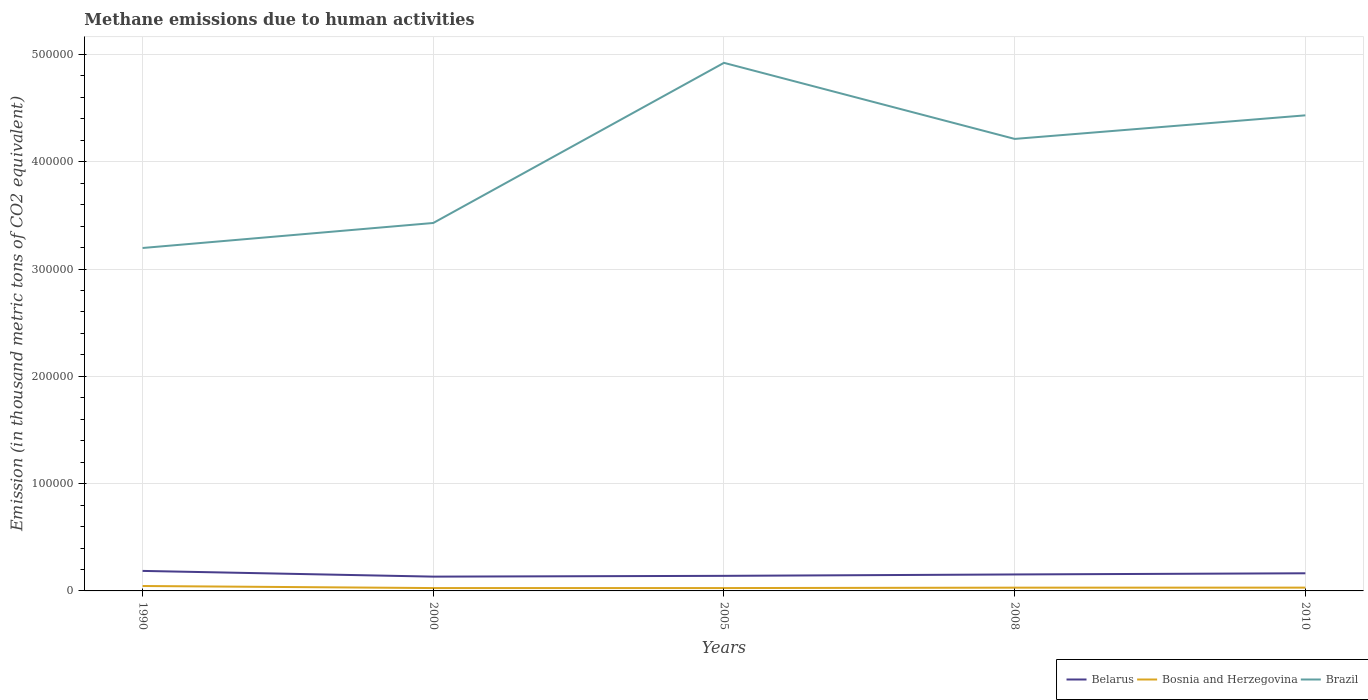Does the line corresponding to Bosnia and Herzegovina intersect with the line corresponding to Belarus?
Your answer should be very brief. No. Across all years, what is the maximum amount of methane emitted in Belarus?
Offer a terse response. 1.33e+04. What is the total amount of methane emitted in Bosnia and Herzegovina in the graph?
Make the answer very short. -399.7. What is the difference between the highest and the second highest amount of methane emitted in Belarus?
Your answer should be compact. 5333.7. Is the amount of methane emitted in Bosnia and Herzegovina strictly greater than the amount of methane emitted in Brazil over the years?
Ensure brevity in your answer.  Yes. How many lines are there?
Offer a very short reply. 3. Are the values on the major ticks of Y-axis written in scientific E-notation?
Your answer should be very brief. No. Does the graph contain any zero values?
Ensure brevity in your answer.  No. How many legend labels are there?
Ensure brevity in your answer.  3. How are the legend labels stacked?
Provide a short and direct response. Horizontal. What is the title of the graph?
Provide a short and direct response. Methane emissions due to human activities. What is the label or title of the X-axis?
Make the answer very short. Years. What is the label or title of the Y-axis?
Your response must be concise. Emission (in thousand metric tons of CO2 equivalent). What is the Emission (in thousand metric tons of CO2 equivalent) in Belarus in 1990?
Keep it short and to the point. 1.87e+04. What is the Emission (in thousand metric tons of CO2 equivalent) in Bosnia and Herzegovina in 1990?
Offer a terse response. 4589.8. What is the Emission (in thousand metric tons of CO2 equivalent) of Brazil in 1990?
Keep it short and to the point. 3.20e+05. What is the Emission (in thousand metric tons of CO2 equivalent) in Belarus in 2000?
Ensure brevity in your answer.  1.33e+04. What is the Emission (in thousand metric tons of CO2 equivalent) in Bosnia and Herzegovina in 2000?
Provide a short and direct response. 2671.7. What is the Emission (in thousand metric tons of CO2 equivalent) in Brazil in 2000?
Ensure brevity in your answer.  3.43e+05. What is the Emission (in thousand metric tons of CO2 equivalent) in Belarus in 2005?
Provide a succinct answer. 1.40e+04. What is the Emission (in thousand metric tons of CO2 equivalent) in Bosnia and Herzegovina in 2005?
Provide a succinct answer. 2665.7. What is the Emission (in thousand metric tons of CO2 equivalent) of Brazil in 2005?
Offer a terse response. 4.92e+05. What is the Emission (in thousand metric tons of CO2 equivalent) of Belarus in 2008?
Provide a short and direct response. 1.53e+04. What is the Emission (in thousand metric tons of CO2 equivalent) in Bosnia and Herzegovina in 2008?
Offer a very short reply. 3037.4. What is the Emission (in thousand metric tons of CO2 equivalent) of Brazil in 2008?
Keep it short and to the point. 4.21e+05. What is the Emission (in thousand metric tons of CO2 equivalent) in Belarus in 2010?
Offer a very short reply. 1.64e+04. What is the Emission (in thousand metric tons of CO2 equivalent) of Bosnia and Herzegovina in 2010?
Keep it short and to the point. 3071.4. What is the Emission (in thousand metric tons of CO2 equivalent) in Brazil in 2010?
Ensure brevity in your answer.  4.43e+05. Across all years, what is the maximum Emission (in thousand metric tons of CO2 equivalent) in Belarus?
Ensure brevity in your answer.  1.87e+04. Across all years, what is the maximum Emission (in thousand metric tons of CO2 equivalent) in Bosnia and Herzegovina?
Keep it short and to the point. 4589.8. Across all years, what is the maximum Emission (in thousand metric tons of CO2 equivalent) of Brazil?
Provide a succinct answer. 4.92e+05. Across all years, what is the minimum Emission (in thousand metric tons of CO2 equivalent) of Belarus?
Your response must be concise. 1.33e+04. Across all years, what is the minimum Emission (in thousand metric tons of CO2 equivalent) of Bosnia and Herzegovina?
Offer a terse response. 2665.7. Across all years, what is the minimum Emission (in thousand metric tons of CO2 equivalent) of Brazil?
Your answer should be very brief. 3.20e+05. What is the total Emission (in thousand metric tons of CO2 equivalent) in Belarus in the graph?
Keep it short and to the point. 7.78e+04. What is the total Emission (in thousand metric tons of CO2 equivalent) in Bosnia and Herzegovina in the graph?
Offer a very short reply. 1.60e+04. What is the total Emission (in thousand metric tons of CO2 equivalent) of Brazil in the graph?
Make the answer very short. 2.02e+06. What is the difference between the Emission (in thousand metric tons of CO2 equivalent) in Belarus in 1990 and that in 2000?
Make the answer very short. 5333.7. What is the difference between the Emission (in thousand metric tons of CO2 equivalent) in Bosnia and Herzegovina in 1990 and that in 2000?
Provide a short and direct response. 1918.1. What is the difference between the Emission (in thousand metric tons of CO2 equivalent) of Brazil in 1990 and that in 2000?
Provide a short and direct response. -2.33e+04. What is the difference between the Emission (in thousand metric tons of CO2 equivalent) of Belarus in 1990 and that in 2005?
Provide a succinct answer. 4610.7. What is the difference between the Emission (in thousand metric tons of CO2 equivalent) in Bosnia and Herzegovina in 1990 and that in 2005?
Give a very brief answer. 1924.1. What is the difference between the Emission (in thousand metric tons of CO2 equivalent) in Brazil in 1990 and that in 2005?
Your answer should be compact. -1.73e+05. What is the difference between the Emission (in thousand metric tons of CO2 equivalent) of Belarus in 1990 and that in 2008?
Your response must be concise. 3312.9. What is the difference between the Emission (in thousand metric tons of CO2 equivalent) in Bosnia and Herzegovina in 1990 and that in 2008?
Keep it short and to the point. 1552.4. What is the difference between the Emission (in thousand metric tons of CO2 equivalent) of Brazil in 1990 and that in 2008?
Provide a succinct answer. -1.02e+05. What is the difference between the Emission (in thousand metric tons of CO2 equivalent) in Belarus in 1990 and that in 2010?
Make the answer very short. 2221. What is the difference between the Emission (in thousand metric tons of CO2 equivalent) in Bosnia and Herzegovina in 1990 and that in 2010?
Make the answer very short. 1518.4. What is the difference between the Emission (in thousand metric tons of CO2 equivalent) of Brazil in 1990 and that in 2010?
Your answer should be compact. -1.24e+05. What is the difference between the Emission (in thousand metric tons of CO2 equivalent) of Belarus in 2000 and that in 2005?
Provide a succinct answer. -723. What is the difference between the Emission (in thousand metric tons of CO2 equivalent) of Bosnia and Herzegovina in 2000 and that in 2005?
Your answer should be very brief. 6. What is the difference between the Emission (in thousand metric tons of CO2 equivalent) in Brazil in 2000 and that in 2005?
Offer a terse response. -1.49e+05. What is the difference between the Emission (in thousand metric tons of CO2 equivalent) of Belarus in 2000 and that in 2008?
Your answer should be compact. -2020.8. What is the difference between the Emission (in thousand metric tons of CO2 equivalent) in Bosnia and Herzegovina in 2000 and that in 2008?
Make the answer very short. -365.7. What is the difference between the Emission (in thousand metric tons of CO2 equivalent) of Brazil in 2000 and that in 2008?
Ensure brevity in your answer.  -7.84e+04. What is the difference between the Emission (in thousand metric tons of CO2 equivalent) in Belarus in 2000 and that in 2010?
Provide a succinct answer. -3112.7. What is the difference between the Emission (in thousand metric tons of CO2 equivalent) in Bosnia and Herzegovina in 2000 and that in 2010?
Offer a very short reply. -399.7. What is the difference between the Emission (in thousand metric tons of CO2 equivalent) of Brazil in 2000 and that in 2010?
Your answer should be compact. -1.00e+05. What is the difference between the Emission (in thousand metric tons of CO2 equivalent) of Belarus in 2005 and that in 2008?
Keep it short and to the point. -1297.8. What is the difference between the Emission (in thousand metric tons of CO2 equivalent) of Bosnia and Herzegovina in 2005 and that in 2008?
Your answer should be very brief. -371.7. What is the difference between the Emission (in thousand metric tons of CO2 equivalent) in Brazil in 2005 and that in 2008?
Keep it short and to the point. 7.09e+04. What is the difference between the Emission (in thousand metric tons of CO2 equivalent) in Belarus in 2005 and that in 2010?
Keep it short and to the point. -2389.7. What is the difference between the Emission (in thousand metric tons of CO2 equivalent) of Bosnia and Herzegovina in 2005 and that in 2010?
Keep it short and to the point. -405.7. What is the difference between the Emission (in thousand metric tons of CO2 equivalent) in Brazil in 2005 and that in 2010?
Your answer should be very brief. 4.89e+04. What is the difference between the Emission (in thousand metric tons of CO2 equivalent) in Belarus in 2008 and that in 2010?
Offer a very short reply. -1091.9. What is the difference between the Emission (in thousand metric tons of CO2 equivalent) in Bosnia and Herzegovina in 2008 and that in 2010?
Provide a short and direct response. -34. What is the difference between the Emission (in thousand metric tons of CO2 equivalent) of Brazil in 2008 and that in 2010?
Offer a terse response. -2.20e+04. What is the difference between the Emission (in thousand metric tons of CO2 equivalent) in Belarus in 1990 and the Emission (in thousand metric tons of CO2 equivalent) in Bosnia and Herzegovina in 2000?
Your answer should be very brief. 1.60e+04. What is the difference between the Emission (in thousand metric tons of CO2 equivalent) in Belarus in 1990 and the Emission (in thousand metric tons of CO2 equivalent) in Brazil in 2000?
Make the answer very short. -3.24e+05. What is the difference between the Emission (in thousand metric tons of CO2 equivalent) in Bosnia and Herzegovina in 1990 and the Emission (in thousand metric tons of CO2 equivalent) in Brazil in 2000?
Your answer should be compact. -3.38e+05. What is the difference between the Emission (in thousand metric tons of CO2 equivalent) in Belarus in 1990 and the Emission (in thousand metric tons of CO2 equivalent) in Bosnia and Herzegovina in 2005?
Your answer should be compact. 1.60e+04. What is the difference between the Emission (in thousand metric tons of CO2 equivalent) in Belarus in 1990 and the Emission (in thousand metric tons of CO2 equivalent) in Brazil in 2005?
Offer a very short reply. -4.74e+05. What is the difference between the Emission (in thousand metric tons of CO2 equivalent) in Bosnia and Herzegovina in 1990 and the Emission (in thousand metric tons of CO2 equivalent) in Brazil in 2005?
Your answer should be compact. -4.88e+05. What is the difference between the Emission (in thousand metric tons of CO2 equivalent) of Belarus in 1990 and the Emission (in thousand metric tons of CO2 equivalent) of Bosnia and Herzegovina in 2008?
Offer a very short reply. 1.56e+04. What is the difference between the Emission (in thousand metric tons of CO2 equivalent) in Belarus in 1990 and the Emission (in thousand metric tons of CO2 equivalent) in Brazil in 2008?
Your answer should be compact. -4.03e+05. What is the difference between the Emission (in thousand metric tons of CO2 equivalent) in Bosnia and Herzegovina in 1990 and the Emission (in thousand metric tons of CO2 equivalent) in Brazil in 2008?
Keep it short and to the point. -4.17e+05. What is the difference between the Emission (in thousand metric tons of CO2 equivalent) of Belarus in 1990 and the Emission (in thousand metric tons of CO2 equivalent) of Bosnia and Herzegovina in 2010?
Keep it short and to the point. 1.56e+04. What is the difference between the Emission (in thousand metric tons of CO2 equivalent) in Belarus in 1990 and the Emission (in thousand metric tons of CO2 equivalent) in Brazil in 2010?
Your answer should be very brief. -4.25e+05. What is the difference between the Emission (in thousand metric tons of CO2 equivalent) of Bosnia and Herzegovina in 1990 and the Emission (in thousand metric tons of CO2 equivalent) of Brazil in 2010?
Give a very brief answer. -4.39e+05. What is the difference between the Emission (in thousand metric tons of CO2 equivalent) of Belarus in 2000 and the Emission (in thousand metric tons of CO2 equivalent) of Bosnia and Herzegovina in 2005?
Offer a very short reply. 1.07e+04. What is the difference between the Emission (in thousand metric tons of CO2 equivalent) of Belarus in 2000 and the Emission (in thousand metric tons of CO2 equivalent) of Brazil in 2005?
Offer a terse response. -4.79e+05. What is the difference between the Emission (in thousand metric tons of CO2 equivalent) of Bosnia and Herzegovina in 2000 and the Emission (in thousand metric tons of CO2 equivalent) of Brazil in 2005?
Ensure brevity in your answer.  -4.90e+05. What is the difference between the Emission (in thousand metric tons of CO2 equivalent) in Belarus in 2000 and the Emission (in thousand metric tons of CO2 equivalent) in Bosnia and Herzegovina in 2008?
Your answer should be very brief. 1.03e+04. What is the difference between the Emission (in thousand metric tons of CO2 equivalent) in Belarus in 2000 and the Emission (in thousand metric tons of CO2 equivalent) in Brazil in 2008?
Provide a short and direct response. -4.08e+05. What is the difference between the Emission (in thousand metric tons of CO2 equivalent) in Bosnia and Herzegovina in 2000 and the Emission (in thousand metric tons of CO2 equivalent) in Brazil in 2008?
Offer a terse response. -4.19e+05. What is the difference between the Emission (in thousand metric tons of CO2 equivalent) of Belarus in 2000 and the Emission (in thousand metric tons of CO2 equivalent) of Bosnia and Herzegovina in 2010?
Offer a terse response. 1.03e+04. What is the difference between the Emission (in thousand metric tons of CO2 equivalent) of Belarus in 2000 and the Emission (in thousand metric tons of CO2 equivalent) of Brazil in 2010?
Your response must be concise. -4.30e+05. What is the difference between the Emission (in thousand metric tons of CO2 equivalent) of Bosnia and Herzegovina in 2000 and the Emission (in thousand metric tons of CO2 equivalent) of Brazil in 2010?
Keep it short and to the point. -4.41e+05. What is the difference between the Emission (in thousand metric tons of CO2 equivalent) in Belarus in 2005 and the Emission (in thousand metric tons of CO2 equivalent) in Bosnia and Herzegovina in 2008?
Ensure brevity in your answer.  1.10e+04. What is the difference between the Emission (in thousand metric tons of CO2 equivalent) in Belarus in 2005 and the Emission (in thousand metric tons of CO2 equivalent) in Brazil in 2008?
Give a very brief answer. -4.07e+05. What is the difference between the Emission (in thousand metric tons of CO2 equivalent) in Bosnia and Herzegovina in 2005 and the Emission (in thousand metric tons of CO2 equivalent) in Brazil in 2008?
Provide a short and direct response. -4.19e+05. What is the difference between the Emission (in thousand metric tons of CO2 equivalent) of Belarus in 2005 and the Emission (in thousand metric tons of CO2 equivalent) of Bosnia and Herzegovina in 2010?
Keep it short and to the point. 1.10e+04. What is the difference between the Emission (in thousand metric tons of CO2 equivalent) of Belarus in 2005 and the Emission (in thousand metric tons of CO2 equivalent) of Brazil in 2010?
Your answer should be very brief. -4.29e+05. What is the difference between the Emission (in thousand metric tons of CO2 equivalent) in Bosnia and Herzegovina in 2005 and the Emission (in thousand metric tons of CO2 equivalent) in Brazil in 2010?
Give a very brief answer. -4.41e+05. What is the difference between the Emission (in thousand metric tons of CO2 equivalent) of Belarus in 2008 and the Emission (in thousand metric tons of CO2 equivalent) of Bosnia and Herzegovina in 2010?
Make the answer very short. 1.23e+04. What is the difference between the Emission (in thousand metric tons of CO2 equivalent) of Belarus in 2008 and the Emission (in thousand metric tons of CO2 equivalent) of Brazil in 2010?
Offer a very short reply. -4.28e+05. What is the difference between the Emission (in thousand metric tons of CO2 equivalent) in Bosnia and Herzegovina in 2008 and the Emission (in thousand metric tons of CO2 equivalent) in Brazil in 2010?
Offer a terse response. -4.40e+05. What is the average Emission (in thousand metric tons of CO2 equivalent) in Belarus per year?
Ensure brevity in your answer.  1.56e+04. What is the average Emission (in thousand metric tons of CO2 equivalent) in Bosnia and Herzegovina per year?
Give a very brief answer. 3207.2. What is the average Emission (in thousand metric tons of CO2 equivalent) of Brazil per year?
Your answer should be compact. 4.04e+05. In the year 1990, what is the difference between the Emission (in thousand metric tons of CO2 equivalent) of Belarus and Emission (in thousand metric tons of CO2 equivalent) of Bosnia and Herzegovina?
Your response must be concise. 1.41e+04. In the year 1990, what is the difference between the Emission (in thousand metric tons of CO2 equivalent) of Belarus and Emission (in thousand metric tons of CO2 equivalent) of Brazil?
Keep it short and to the point. -3.01e+05. In the year 1990, what is the difference between the Emission (in thousand metric tons of CO2 equivalent) in Bosnia and Herzegovina and Emission (in thousand metric tons of CO2 equivalent) in Brazil?
Your answer should be very brief. -3.15e+05. In the year 2000, what is the difference between the Emission (in thousand metric tons of CO2 equivalent) in Belarus and Emission (in thousand metric tons of CO2 equivalent) in Bosnia and Herzegovina?
Your answer should be compact. 1.07e+04. In the year 2000, what is the difference between the Emission (in thousand metric tons of CO2 equivalent) of Belarus and Emission (in thousand metric tons of CO2 equivalent) of Brazil?
Offer a very short reply. -3.30e+05. In the year 2000, what is the difference between the Emission (in thousand metric tons of CO2 equivalent) of Bosnia and Herzegovina and Emission (in thousand metric tons of CO2 equivalent) of Brazil?
Give a very brief answer. -3.40e+05. In the year 2005, what is the difference between the Emission (in thousand metric tons of CO2 equivalent) in Belarus and Emission (in thousand metric tons of CO2 equivalent) in Bosnia and Herzegovina?
Provide a succinct answer. 1.14e+04. In the year 2005, what is the difference between the Emission (in thousand metric tons of CO2 equivalent) of Belarus and Emission (in thousand metric tons of CO2 equivalent) of Brazil?
Offer a very short reply. -4.78e+05. In the year 2005, what is the difference between the Emission (in thousand metric tons of CO2 equivalent) in Bosnia and Herzegovina and Emission (in thousand metric tons of CO2 equivalent) in Brazil?
Ensure brevity in your answer.  -4.90e+05. In the year 2008, what is the difference between the Emission (in thousand metric tons of CO2 equivalent) of Belarus and Emission (in thousand metric tons of CO2 equivalent) of Bosnia and Herzegovina?
Your answer should be very brief. 1.23e+04. In the year 2008, what is the difference between the Emission (in thousand metric tons of CO2 equivalent) of Belarus and Emission (in thousand metric tons of CO2 equivalent) of Brazil?
Keep it short and to the point. -4.06e+05. In the year 2008, what is the difference between the Emission (in thousand metric tons of CO2 equivalent) of Bosnia and Herzegovina and Emission (in thousand metric tons of CO2 equivalent) of Brazil?
Offer a very short reply. -4.18e+05. In the year 2010, what is the difference between the Emission (in thousand metric tons of CO2 equivalent) in Belarus and Emission (in thousand metric tons of CO2 equivalent) in Bosnia and Herzegovina?
Offer a very short reply. 1.34e+04. In the year 2010, what is the difference between the Emission (in thousand metric tons of CO2 equivalent) in Belarus and Emission (in thousand metric tons of CO2 equivalent) in Brazil?
Offer a terse response. -4.27e+05. In the year 2010, what is the difference between the Emission (in thousand metric tons of CO2 equivalent) in Bosnia and Herzegovina and Emission (in thousand metric tons of CO2 equivalent) in Brazil?
Make the answer very short. -4.40e+05. What is the ratio of the Emission (in thousand metric tons of CO2 equivalent) of Belarus in 1990 to that in 2000?
Keep it short and to the point. 1.4. What is the ratio of the Emission (in thousand metric tons of CO2 equivalent) in Bosnia and Herzegovina in 1990 to that in 2000?
Your response must be concise. 1.72. What is the ratio of the Emission (in thousand metric tons of CO2 equivalent) in Brazil in 1990 to that in 2000?
Offer a very short reply. 0.93. What is the ratio of the Emission (in thousand metric tons of CO2 equivalent) of Belarus in 1990 to that in 2005?
Offer a terse response. 1.33. What is the ratio of the Emission (in thousand metric tons of CO2 equivalent) of Bosnia and Herzegovina in 1990 to that in 2005?
Your answer should be very brief. 1.72. What is the ratio of the Emission (in thousand metric tons of CO2 equivalent) of Brazil in 1990 to that in 2005?
Provide a succinct answer. 0.65. What is the ratio of the Emission (in thousand metric tons of CO2 equivalent) in Belarus in 1990 to that in 2008?
Offer a very short reply. 1.22. What is the ratio of the Emission (in thousand metric tons of CO2 equivalent) in Bosnia and Herzegovina in 1990 to that in 2008?
Your answer should be compact. 1.51. What is the ratio of the Emission (in thousand metric tons of CO2 equivalent) of Brazil in 1990 to that in 2008?
Keep it short and to the point. 0.76. What is the ratio of the Emission (in thousand metric tons of CO2 equivalent) of Belarus in 1990 to that in 2010?
Offer a terse response. 1.14. What is the ratio of the Emission (in thousand metric tons of CO2 equivalent) in Bosnia and Herzegovina in 1990 to that in 2010?
Your answer should be very brief. 1.49. What is the ratio of the Emission (in thousand metric tons of CO2 equivalent) of Brazil in 1990 to that in 2010?
Offer a very short reply. 0.72. What is the ratio of the Emission (in thousand metric tons of CO2 equivalent) of Belarus in 2000 to that in 2005?
Provide a succinct answer. 0.95. What is the ratio of the Emission (in thousand metric tons of CO2 equivalent) of Brazil in 2000 to that in 2005?
Provide a succinct answer. 0.7. What is the ratio of the Emission (in thousand metric tons of CO2 equivalent) in Belarus in 2000 to that in 2008?
Ensure brevity in your answer.  0.87. What is the ratio of the Emission (in thousand metric tons of CO2 equivalent) in Bosnia and Herzegovina in 2000 to that in 2008?
Ensure brevity in your answer.  0.88. What is the ratio of the Emission (in thousand metric tons of CO2 equivalent) of Brazil in 2000 to that in 2008?
Provide a short and direct response. 0.81. What is the ratio of the Emission (in thousand metric tons of CO2 equivalent) of Belarus in 2000 to that in 2010?
Make the answer very short. 0.81. What is the ratio of the Emission (in thousand metric tons of CO2 equivalent) in Bosnia and Herzegovina in 2000 to that in 2010?
Give a very brief answer. 0.87. What is the ratio of the Emission (in thousand metric tons of CO2 equivalent) in Brazil in 2000 to that in 2010?
Give a very brief answer. 0.77. What is the ratio of the Emission (in thousand metric tons of CO2 equivalent) of Belarus in 2005 to that in 2008?
Your response must be concise. 0.92. What is the ratio of the Emission (in thousand metric tons of CO2 equivalent) in Bosnia and Herzegovina in 2005 to that in 2008?
Offer a very short reply. 0.88. What is the ratio of the Emission (in thousand metric tons of CO2 equivalent) in Brazil in 2005 to that in 2008?
Provide a short and direct response. 1.17. What is the ratio of the Emission (in thousand metric tons of CO2 equivalent) in Belarus in 2005 to that in 2010?
Your answer should be compact. 0.85. What is the ratio of the Emission (in thousand metric tons of CO2 equivalent) of Bosnia and Herzegovina in 2005 to that in 2010?
Offer a terse response. 0.87. What is the ratio of the Emission (in thousand metric tons of CO2 equivalent) in Brazil in 2005 to that in 2010?
Your answer should be compact. 1.11. What is the ratio of the Emission (in thousand metric tons of CO2 equivalent) of Belarus in 2008 to that in 2010?
Give a very brief answer. 0.93. What is the ratio of the Emission (in thousand metric tons of CO2 equivalent) in Bosnia and Herzegovina in 2008 to that in 2010?
Your answer should be compact. 0.99. What is the ratio of the Emission (in thousand metric tons of CO2 equivalent) of Brazil in 2008 to that in 2010?
Ensure brevity in your answer.  0.95. What is the difference between the highest and the second highest Emission (in thousand metric tons of CO2 equivalent) in Belarus?
Give a very brief answer. 2221. What is the difference between the highest and the second highest Emission (in thousand metric tons of CO2 equivalent) in Bosnia and Herzegovina?
Offer a very short reply. 1518.4. What is the difference between the highest and the second highest Emission (in thousand metric tons of CO2 equivalent) of Brazil?
Give a very brief answer. 4.89e+04. What is the difference between the highest and the lowest Emission (in thousand metric tons of CO2 equivalent) of Belarus?
Your answer should be compact. 5333.7. What is the difference between the highest and the lowest Emission (in thousand metric tons of CO2 equivalent) of Bosnia and Herzegovina?
Your answer should be very brief. 1924.1. What is the difference between the highest and the lowest Emission (in thousand metric tons of CO2 equivalent) in Brazil?
Your response must be concise. 1.73e+05. 